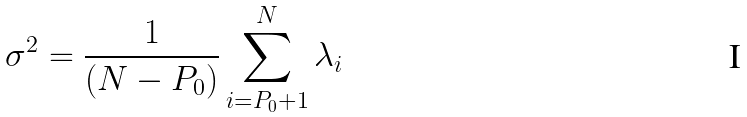<formula> <loc_0><loc_0><loc_500><loc_500>\sigma ^ { 2 } = \frac { 1 } { ( N - P _ { 0 } ) } \sum _ { i = P _ { 0 } + 1 } ^ { N } \lambda _ { i }</formula> 